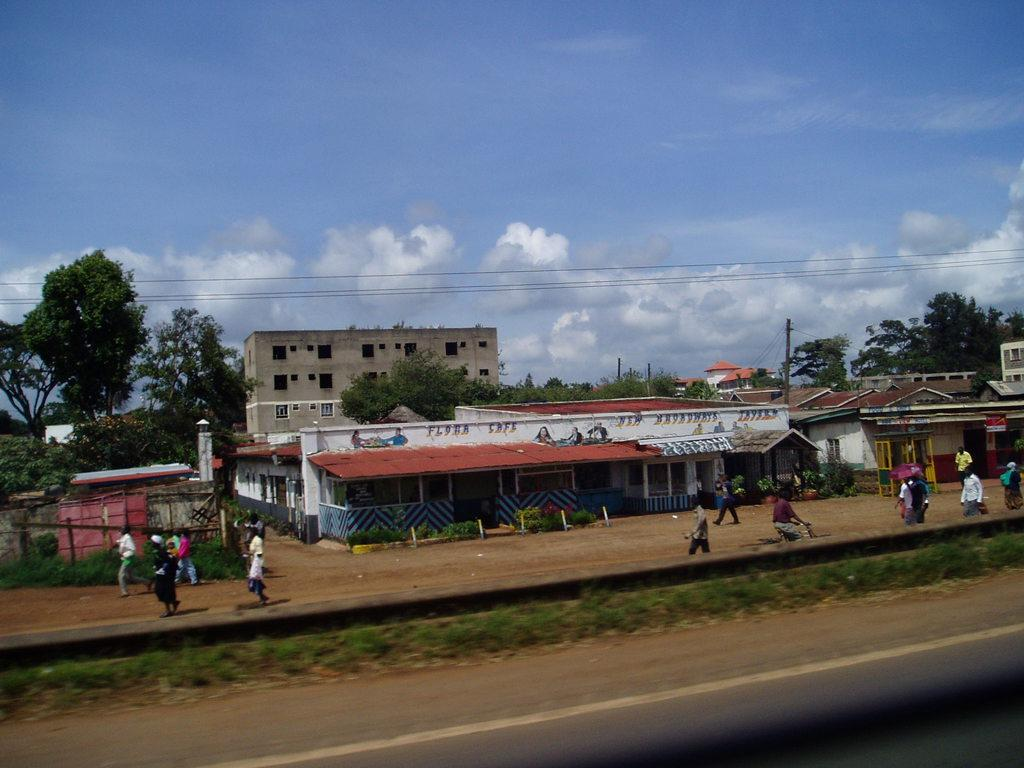What type of surface is visible on the ground in the image? There is grass on the ground in the image. What are the people in the background doing? There are persons walking and standing in the background. What structures can be seen in the background? There are buildings in the background. What other natural elements are present in the background? There are trees in the background. How would you describe the weather based on the image? The sky is cloudy in the image. What else can be seen in the image besides the grass, people, buildings, and trees? There are there any other objects or features? What language are the people in the image speaking? There is no information about the language being spoken in the image. Can you tell if the people in the image are angry or happy? There is no indication of the emotions of the people in the image. 